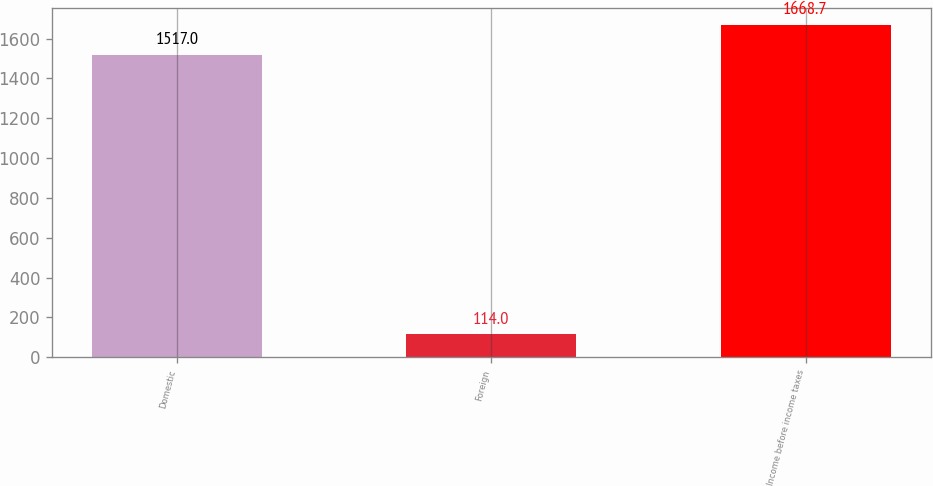Convert chart to OTSL. <chart><loc_0><loc_0><loc_500><loc_500><bar_chart><fcel>Domestic<fcel>Foreign<fcel>Income before income taxes<nl><fcel>1517<fcel>114<fcel>1668.7<nl></chart> 